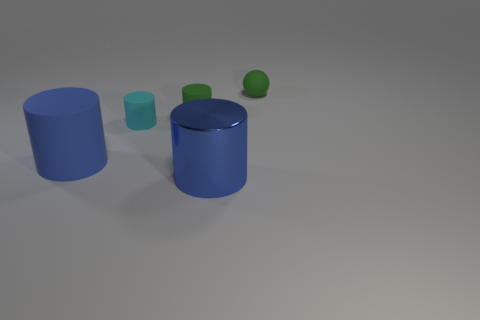Subtract all purple cylinders. Subtract all cyan blocks. How many cylinders are left? 4 Add 4 small green things. How many objects exist? 9 Subtract all cylinders. How many objects are left? 1 Subtract all green metallic blocks. Subtract all small green rubber balls. How many objects are left? 4 Add 5 blue cylinders. How many blue cylinders are left? 7 Add 4 balls. How many balls exist? 5 Subtract 0 yellow balls. How many objects are left? 5 